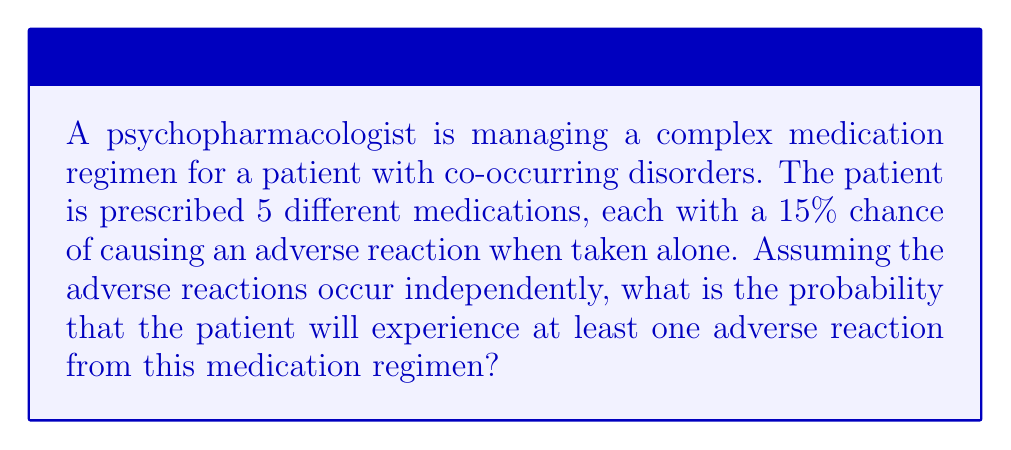Can you solve this math problem? Let's approach this step-by-step:

1) First, we need to calculate the probability of not experiencing an adverse reaction from a single medication:
   $P(\text{no adverse reaction}) = 1 - 0.15 = 0.85$ or 85%

2) Since the patient is taking 5 medications and the reactions are independent, we can use the multiplication rule of probability. The probability of not experiencing any adverse reactions is:
   $P(\text{no adverse reactions}) = 0.85^5$

3) We can calculate this:
   $0.85^5 \approx 0.4437$ or about 44.37%

4) The question asks for the probability of experiencing at least one adverse reaction. This is the complement of experiencing no adverse reactions. So we subtract our result from 1:
   $P(\text{at least one adverse reaction}) = 1 - P(\text{no adverse reactions})$
   $= 1 - 0.4437 = 0.5563$

5) Therefore, the probability of experiencing at least one adverse reaction is approximately 0.5563 or 55.63%

This can also be calculated directly using the formula:

$$P(\text{at least one adverse reaction}) = 1 - (1 - p)^n$$

Where $p$ is the probability of an adverse reaction from a single medication (0.15), and $n$ is the number of medications (5).

$$1 - (1 - 0.15)^5 = 1 - 0.85^5 \approx 0.5563$$
Answer: The probability that the patient will experience at least one adverse reaction is approximately 0.5563 or 55.63%. 